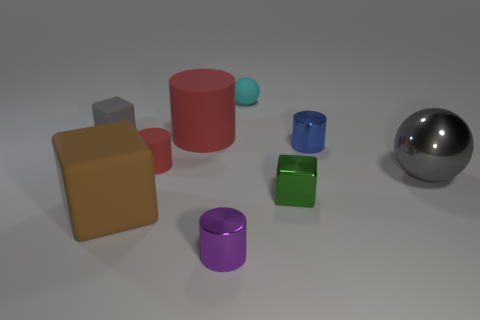What number of cylinders are either small metal objects or purple objects?
Make the answer very short. 2. What number of small cyan things have the same material as the blue thing?
Make the answer very short. 0. The object that is the same color as the big shiny sphere is what shape?
Your answer should be compact. Cube. What is the material of the thing that is on the left side of the small matte cylinder and in front of the gray block?
Your answer should be very brief. Rubber. What is the shape of the large matte thing behind the big gray metal object?
Offer a very short reply. Cylinder. What shape is the big thing right of the large object behind the tiny matte cylinder?
Give a very brief answer. Sphere. Are there any blue shiny objects of the same shape as the cyan matte thing?
Your answer should be very brief. No. The metal thing that is the same size as the brown rubber cube is what shape?
Your response must be concise. Sphere. There is a metal object that is right of the small shiny thing that is behind the big metal object; is there a large cylinder in front of it?
Provide a short and direct response. No. Are there any brown objects that have the same size as the blue cylinder?
Provide a succinct answer. No. 